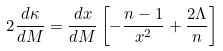<formula> <loc_0><loc_0><loc_500><loc_500>2 \frac { d \kappa } { d M } = \frac { d x } { d M } \left [ - \frac { n - 1 } { x ^ { 2 } } + \frac { 2 \Lambda } { n } \right ]</formula> 